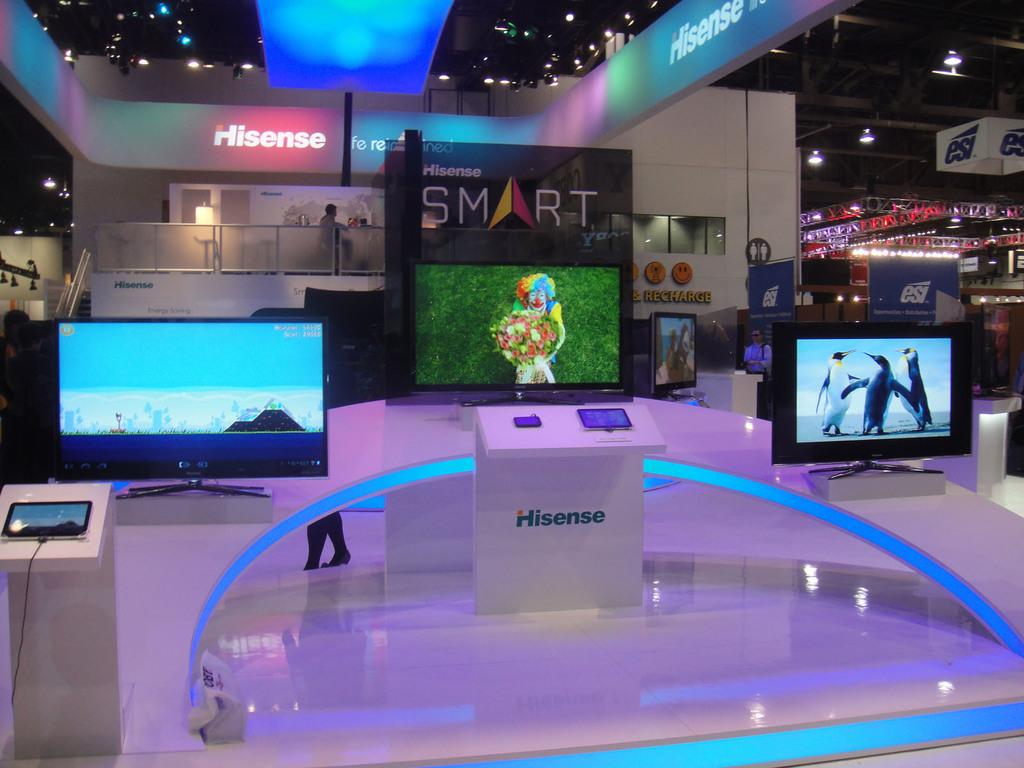<image>
Offer a succinct explanation of the picture presented. Electronics corporation, Hisense display with three smart TVs of various design, at a trade fair. 